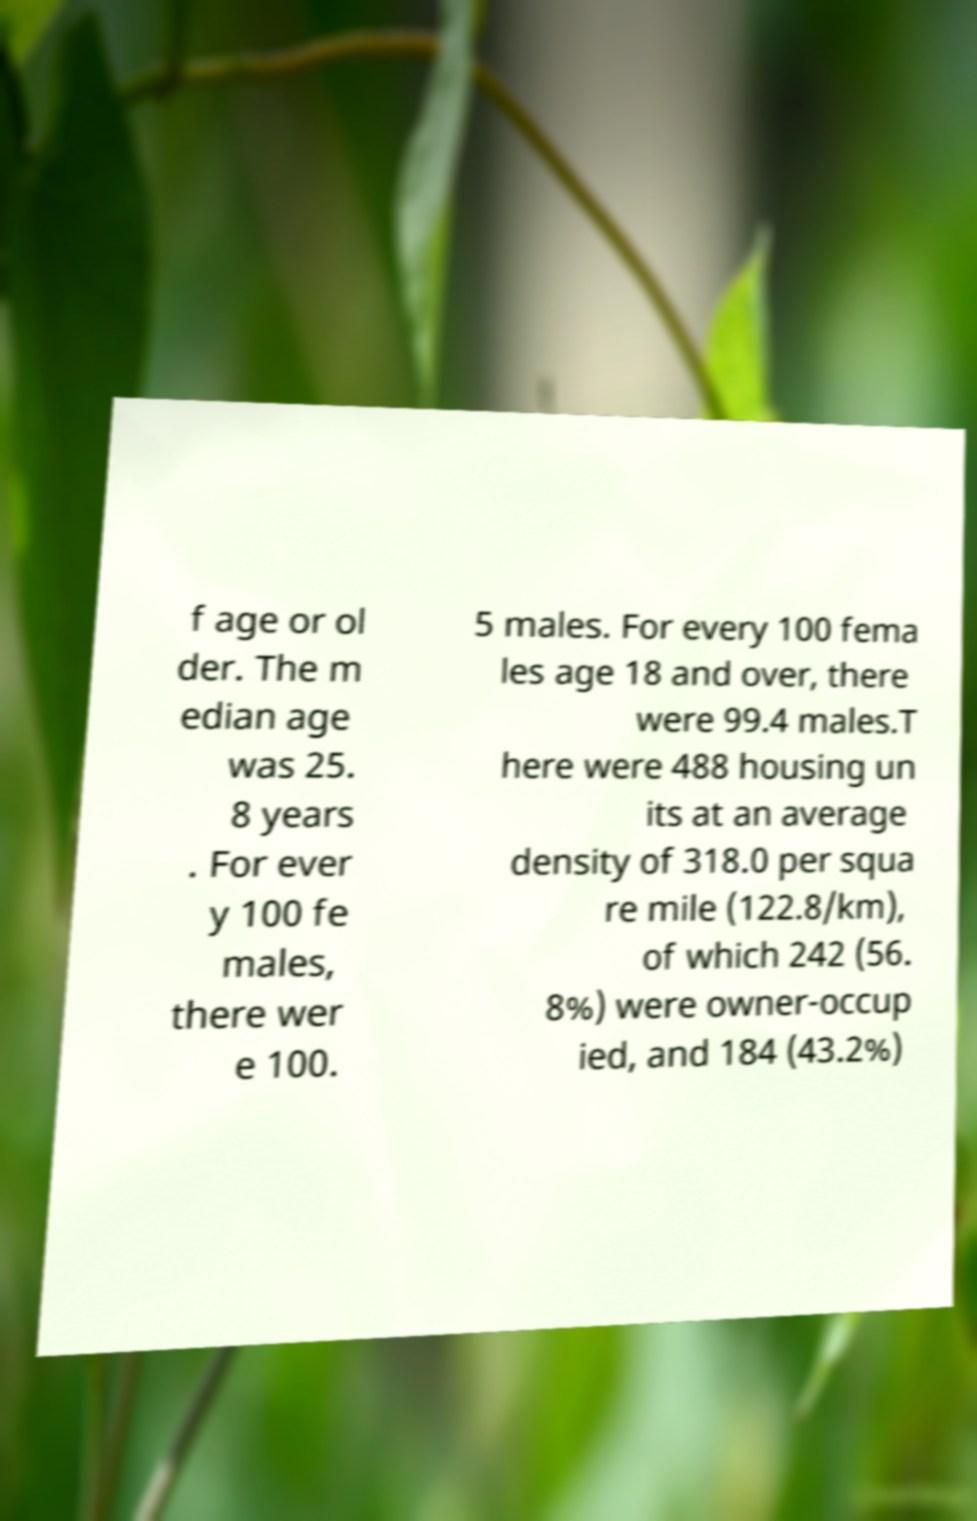Could you assist in decoding the text presented in this image and type it out clearly? f age or ol der. The m edian age was 25. 8 years . For ever y 100 fe males, there wer e 100. 5 males. For every 100 fema les age 18 and over, there were 99.4 males.T here were 488 housing un its at an average density of 318.0 per squa re mile (122.8/km), of which 242 (56. 8%) were owner-occup ied, and 184 (43.2%) 